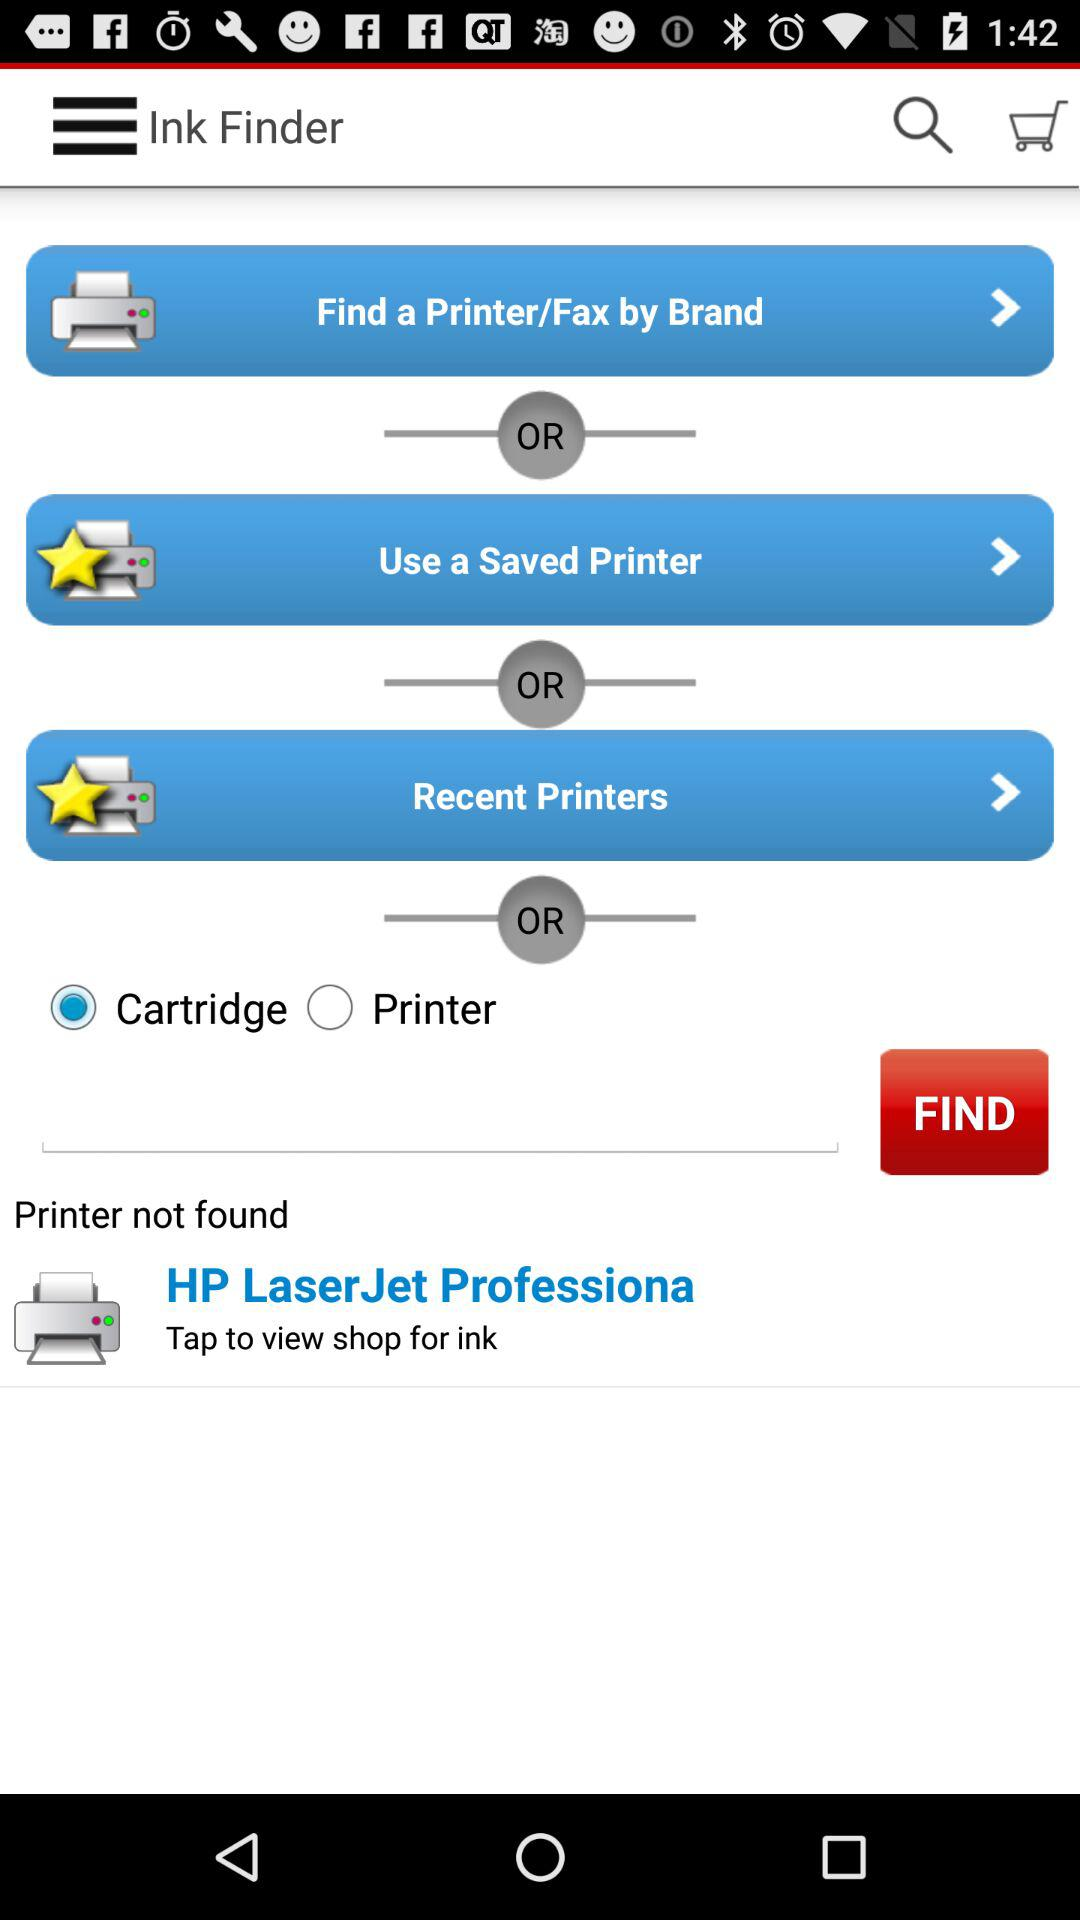What is the application name? The application name is "Ink Finder". 